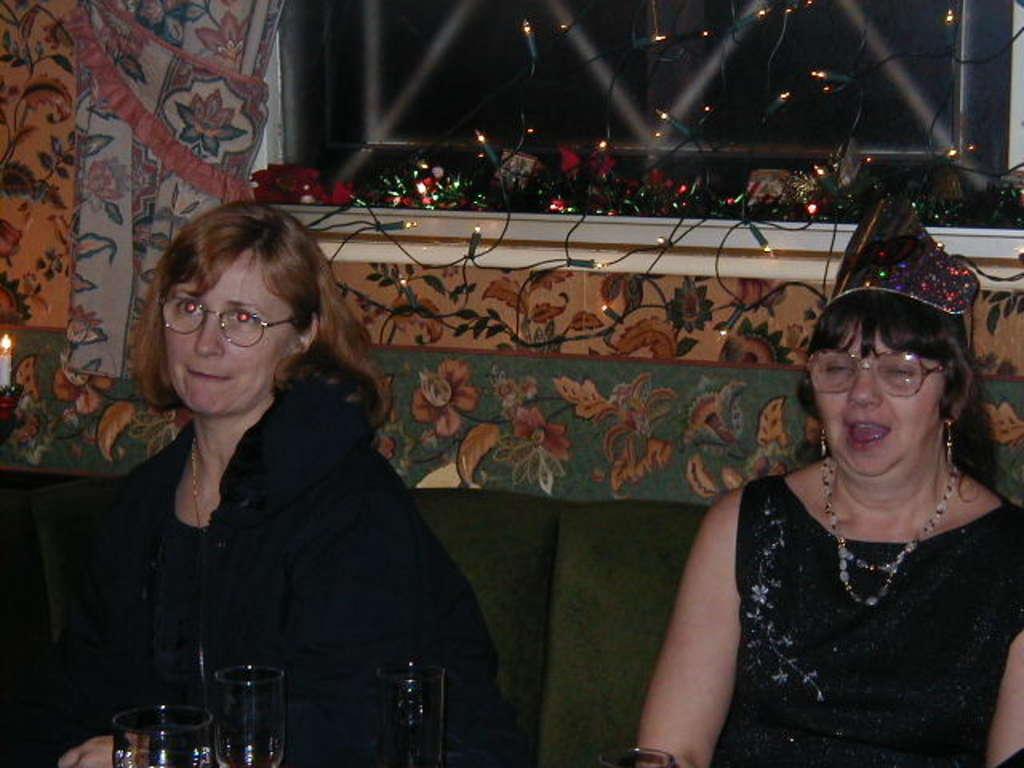How would you summarize this image in a sentence or two? In this image we can see two women sitting on the sofa. In the background we can see curtains, decor lights, window, wall and glass tumblers. 